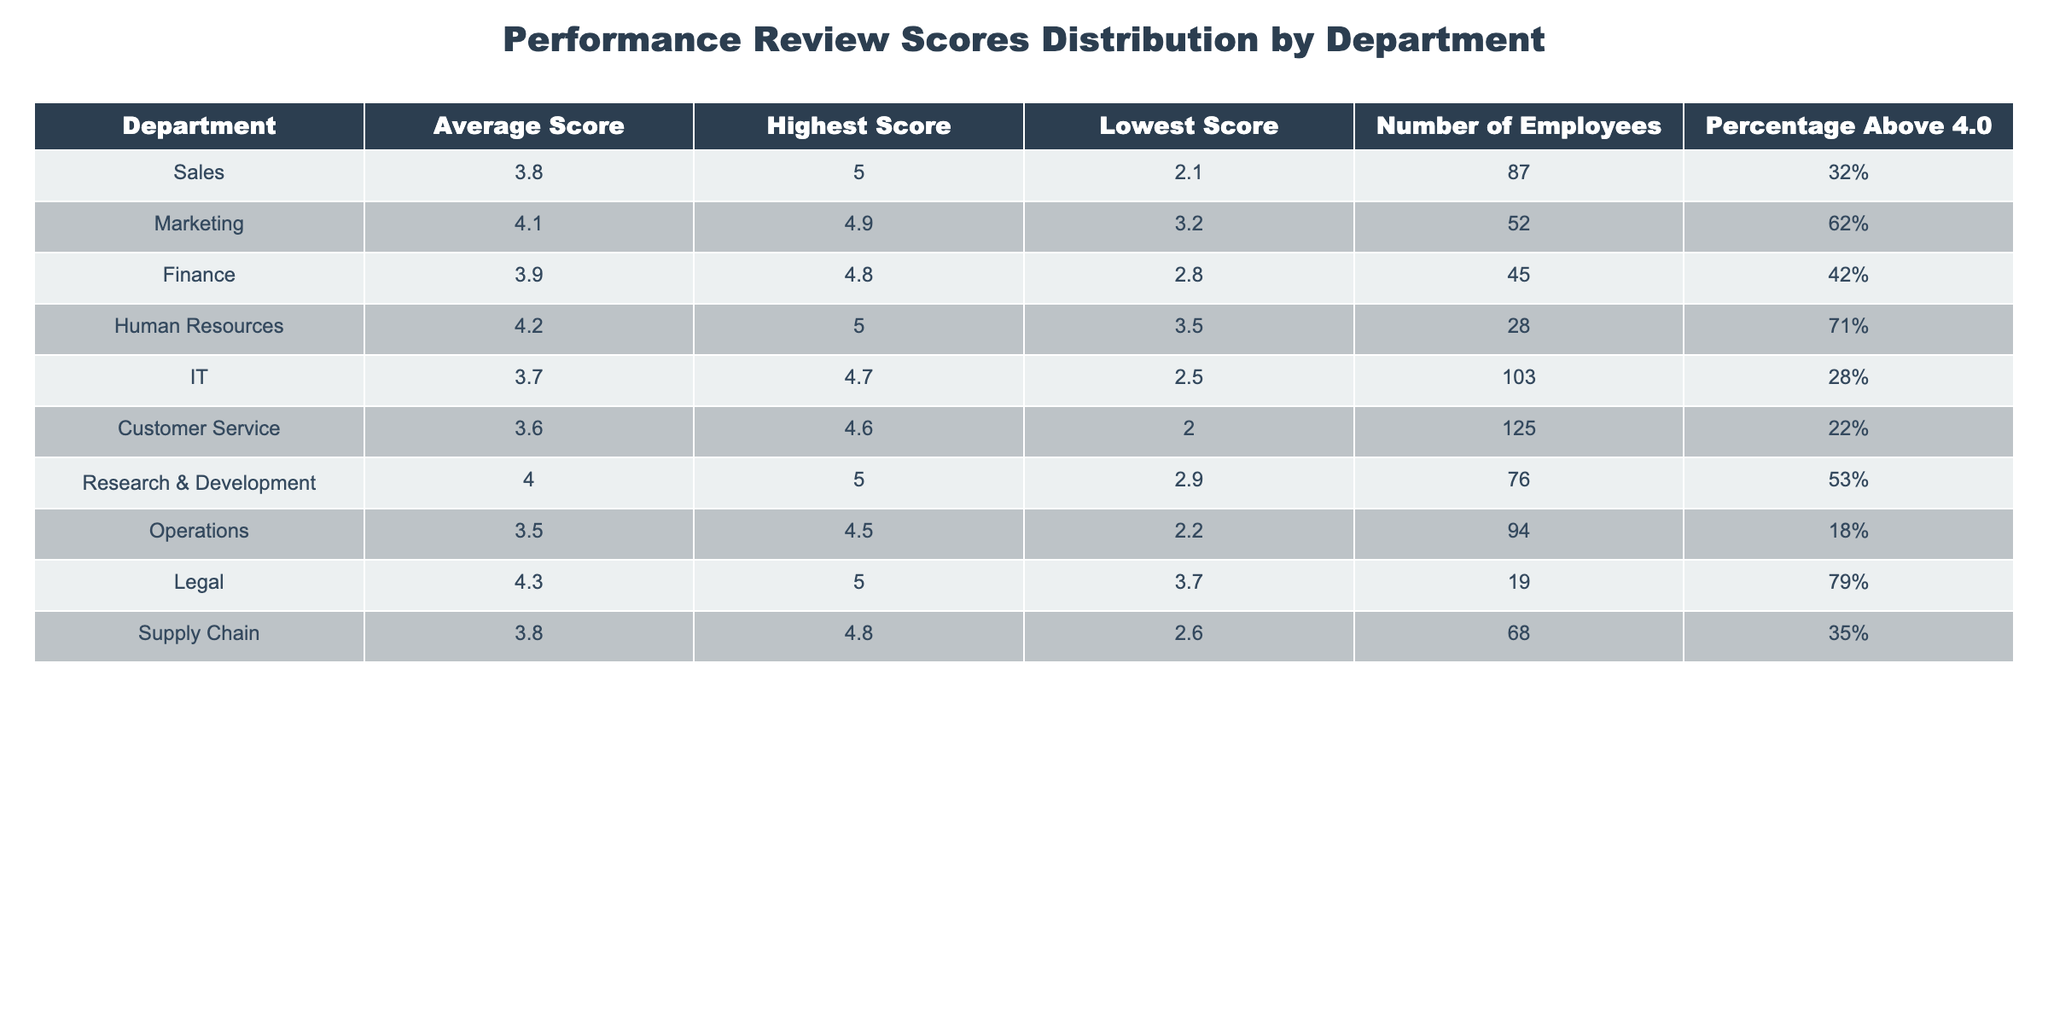What is the average score for the Marketing department? The average score is listed directly in the table under the "Average Score" column for the Marketing department, which is 4.1.
Answer: 4.1 Which department has the highest average score? By reviewing the "Average Score" column, Human Resources has the highest average score at 4.2.
Answer: Human Resources How many employees are in the Customer Service department? The number of employees is specified in the "Number of Employees" column for Customer Service, which shows 125 employees.
Answer: 125 What is the lowest score recorded in the Finance department? The lowest score is provided in the "Lowest Score" column for the Finance department, which is 2.8.
Answer: 2.8 What percentage of employees in the Legal department scored above 4.0? This information is found in the "Percentage Above 4.0" column for the Legal department, indicating 79%.
Answer: 79% What is the difference between the highest score and the lowest score in the Sales department? The highest score for Sales is 5.0 and the lowest score is 2.1. The difference is calculated as (5.0 - 2.1) = 2.9.
Answer: 2.9 Which department has the largest number of employees, and how many are there? By examining the "Number of Employees" column, IT department has the largest count at 103 employees.
Answer: IT, 103 If we consider only departments with an average score above 4.0, how many departments are there? The departments with an average score above 4.0 are Marketing, Human Resources, Legal, and Research & Development, totaling 4 departments.
Answer: 4 What is the average of the highest scores across all departments? We need to sum the highest scores: (5.0 + 4.9 + 4.8 + 5.0 + 4.7 + 4.6 + 5.0 + 4.5 + 5.0) = 44.5, and there are 9 departments. Thus, the average is 44.5 / 9 = 4.94.
Answer: 4.94 Is there a department with no employees scoring above 4.0? The "Percentage Above 4.0" for Customer Service shows 22%, indicating that someone scored above 4.0, therefore, all departments have at least some employees scoring above 4.0.
Answer: No 